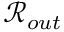Convert formula to latex. <formula><loc_0><loc_0><loc_500><loc_500>\mathcal { R } _ { o u t }</formula> 